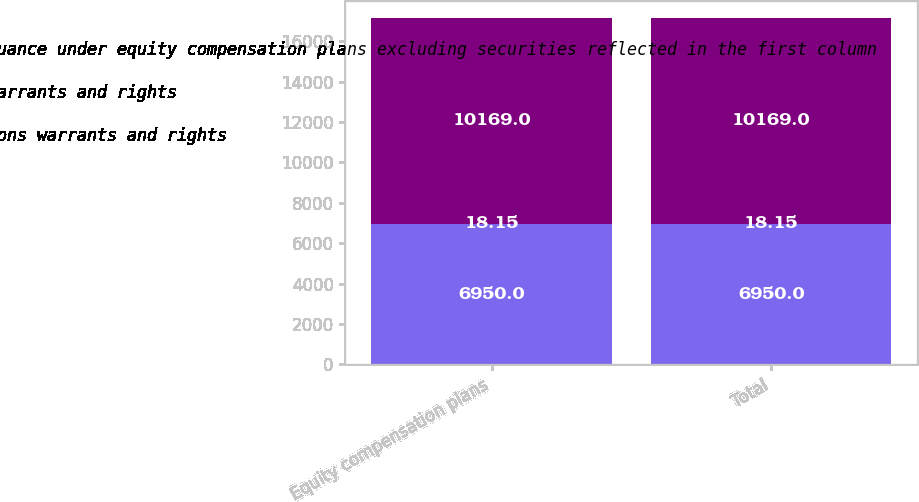Convert chart to OTSL. <chart><loc_0><loc_0><loc_500><loc_500><stacked_bar_chart><ecel><fcel>Equity compensation plans<fcel>Total<nl><fcel>Number of securities remaining available for future issuance under equity compensation plans excluding securities reflected in the first column<fcel>6950<fcel>6950<nl><fcel>Weightedaverage exercise price of outstanding options warrants and rights<fcel>18.15<fcel>18.15<nl><fcel>Number of securities to be issued upon exercise of options warrants and rights<fcel>10169<fcel>10169<nl></chart> 